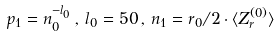Convert formula to latex. <formula><loc_0><loc_0><loc_500><loc_500>p _ { 1 } = n _ { 0 } ^ { - l _ { 0 } } \, , \, l _ { 0 } = 5 0 \, , \, n _ { 1 } = r _ { 0 } / 2 \cdot \langle Z _ { r } ^ { ( 0 ) } \rangle</formula> 